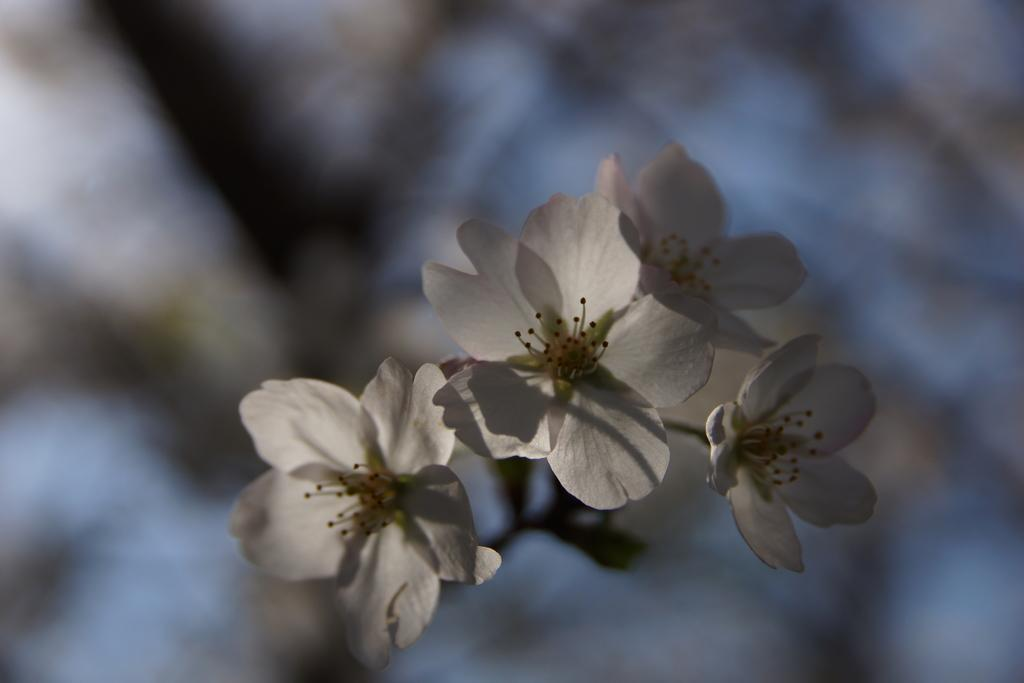What type of plants can be seen in the image? There are flowers in the image. Can you describe the background of the image? The background of the image is blurred. How many boys are using a rake in the image? There are no boys or rakes present in the image; it only features flowers and a blurred background. 